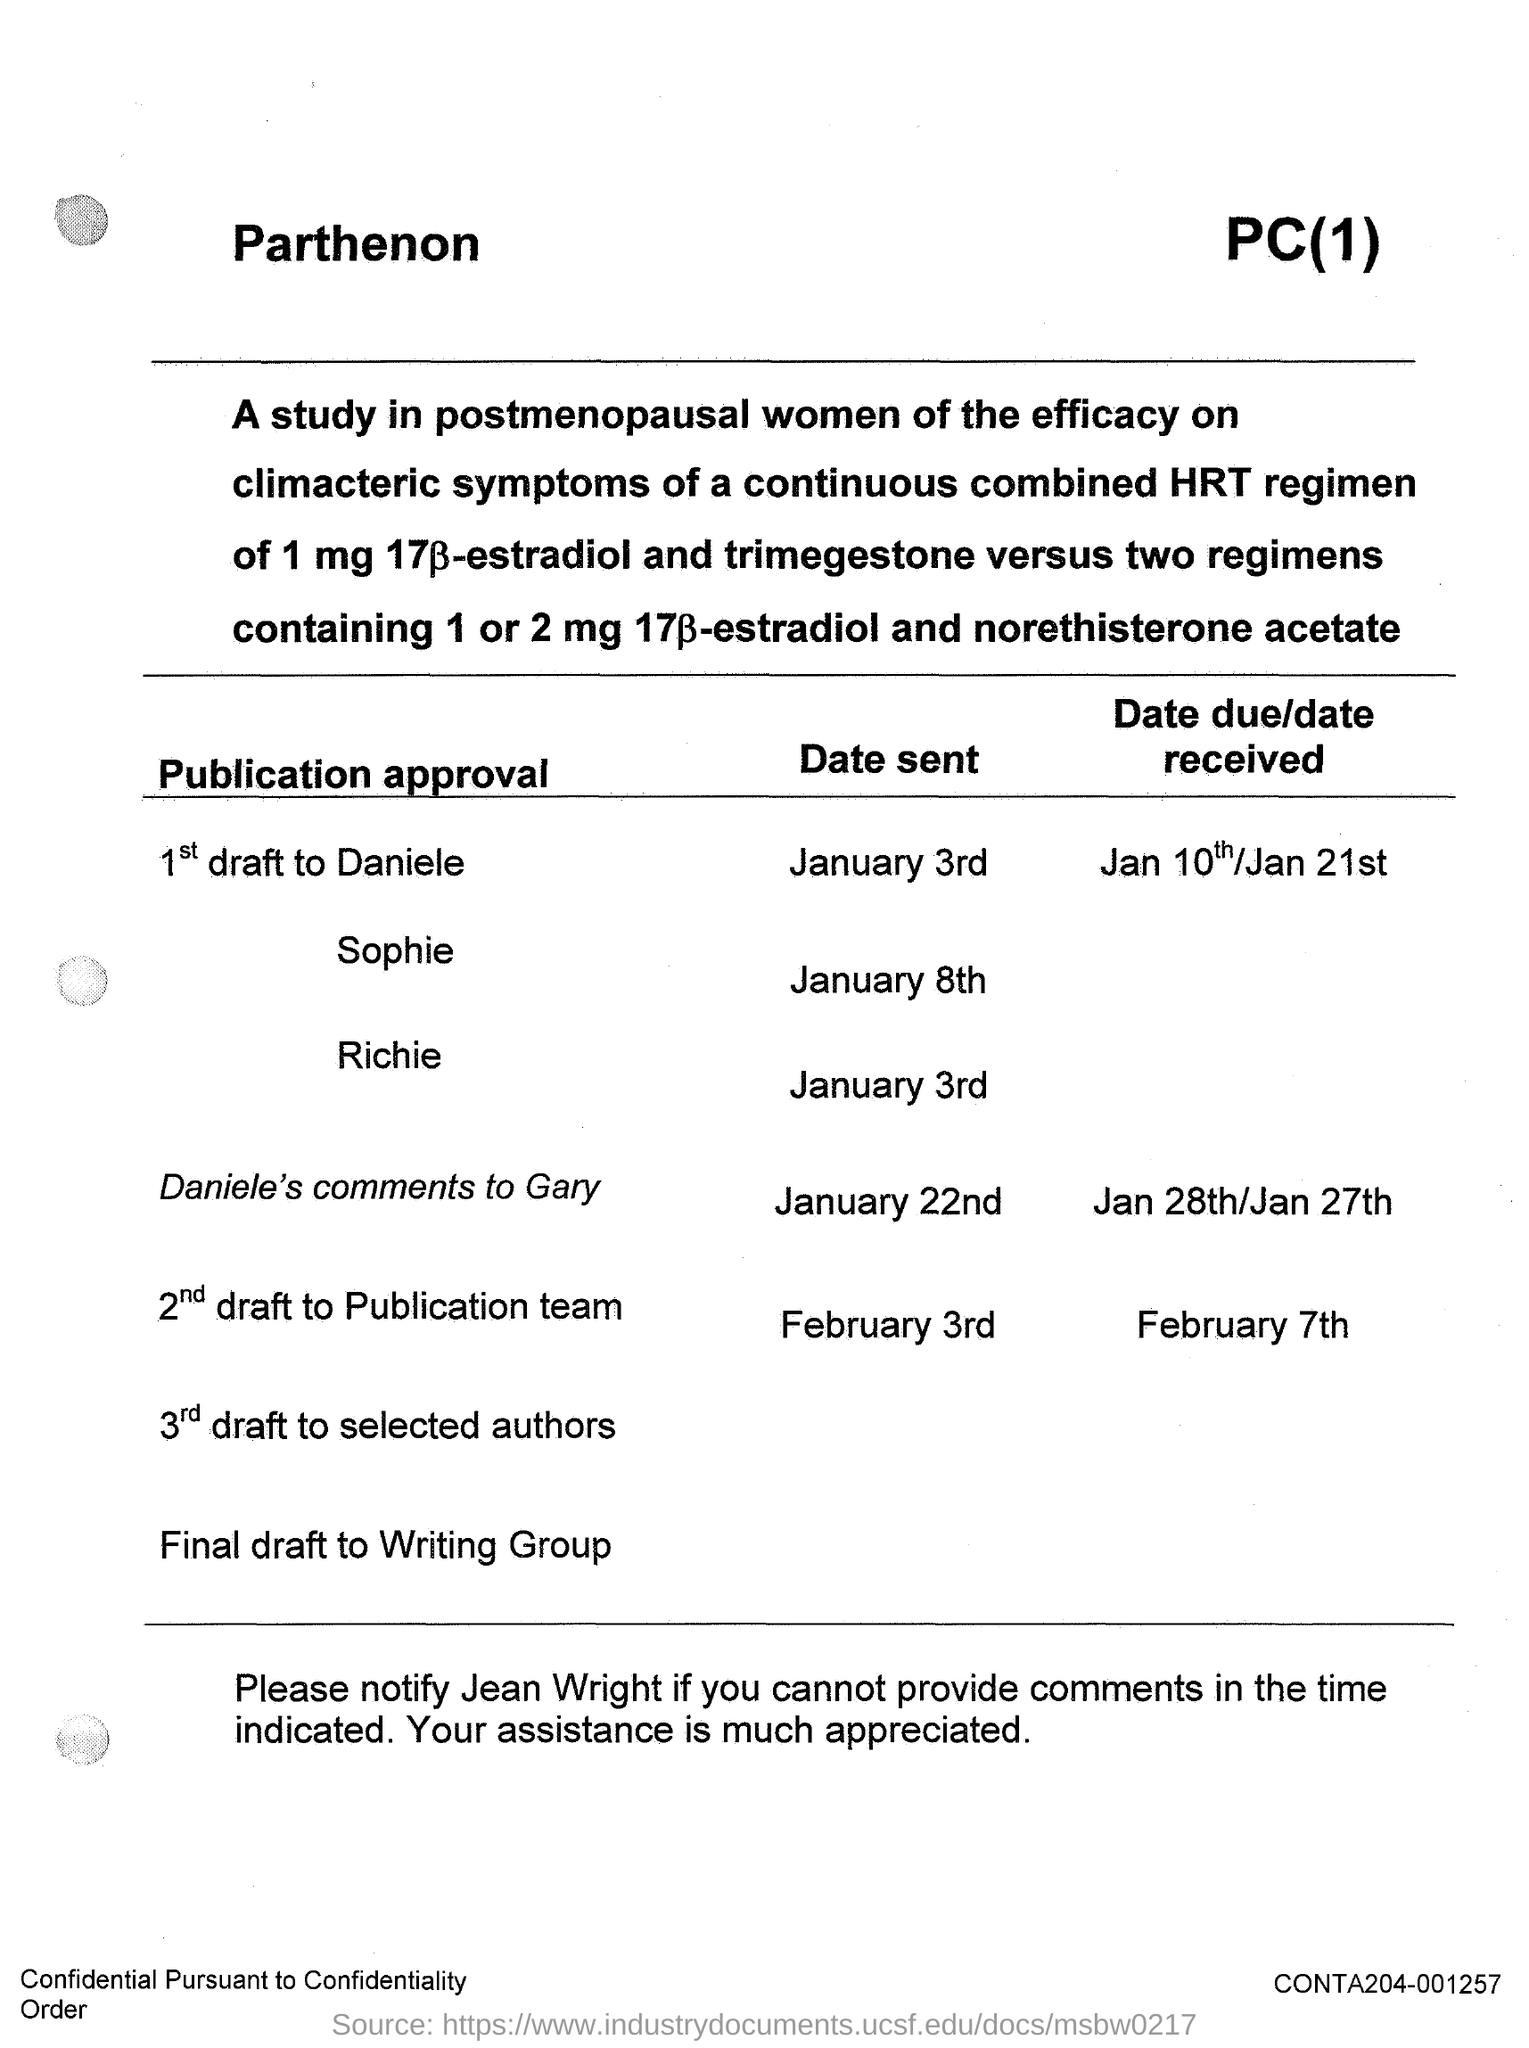What is the date sent of 1st draft to daniele ?
Your answer should be very brief. January 3rd. What is the date sent of sophie mentioned ?
Give a very brief answer. January 8th. What is the date sent of richie mentioned ?
Keep it short and to the point. January 3rd. 